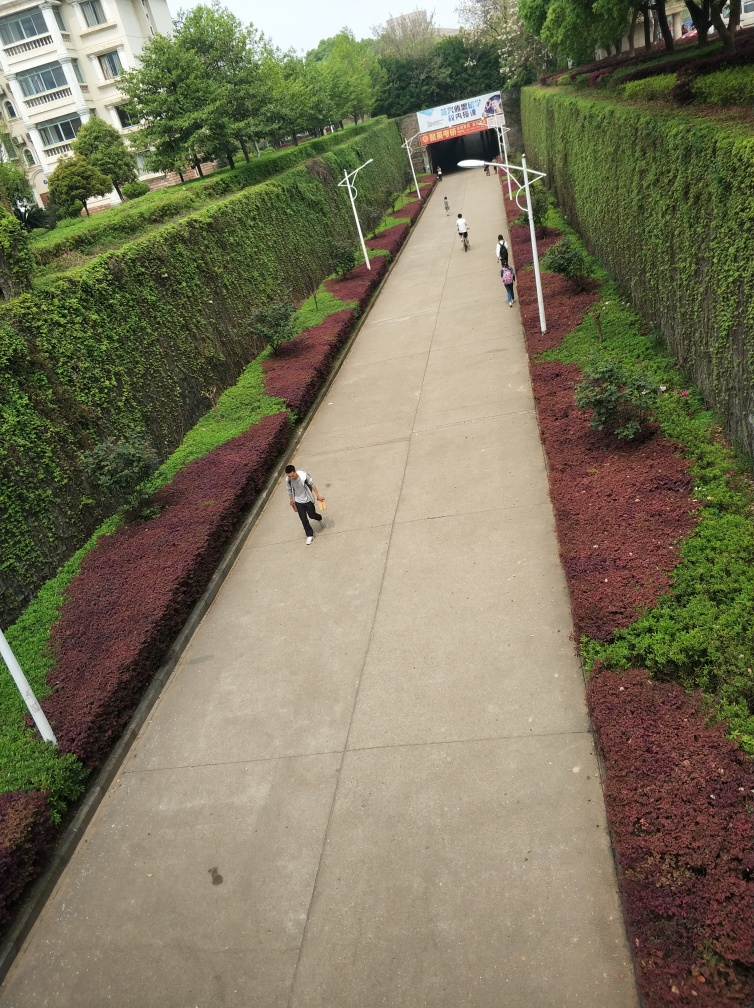Can you describe the surrounding environment of this place? Certainly! The image shows an outdoor urban scene, possibly within a campus or public park. A wide pedestrian path runs down the center, flanked by well-maintained hedges with rich green and purple foliage. Lamp posts line the pathway, suggesting it's well-lit at night. In the background, there is a tunnel entrance with signage above, likely serving as a thoroughfare for pedestrians. The buildings on either side have a uniform, institutional architecture. The overcast sky implies it might be a cool or cloudy day. 